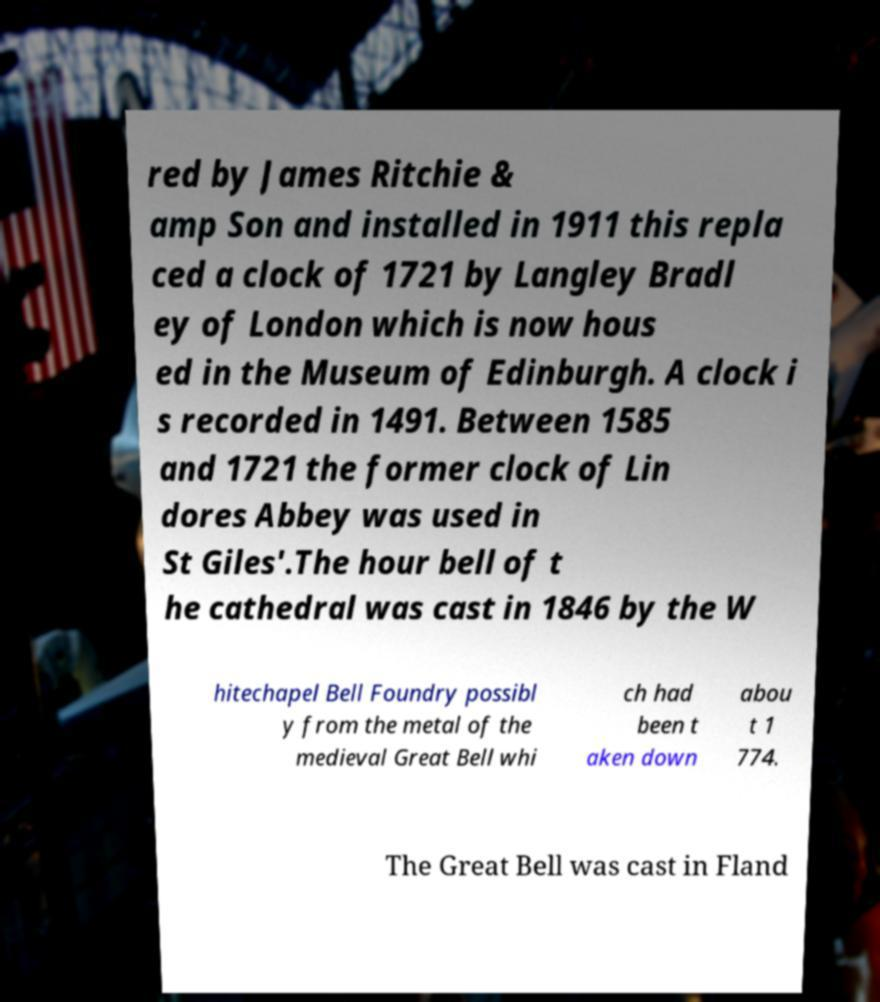Please read and relay the text visible in this image. What does it say? red by James Ritchie & amp Son and installed in 1911 this repla ced a clock of 1721 by Langley Bradl ey of London which is now hous ed in the Museum of Edinburgh. A clock i s recorded in 1491. Between 1585 and 1721 the former clock of Lin dores Abbey was used in St Giles'.The hour bell of t he cathedral was cast in 1846 by the W hitechapel Bell Foundry possibl y from the metal of the medieval Great Bell whi ch had been t aken down abou t 1 774. The Great Bell was cast in Fland 